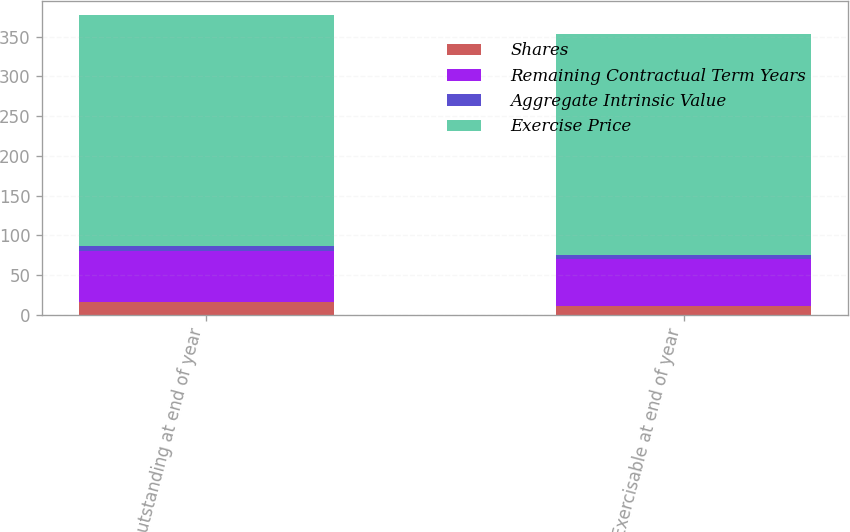<chart> <loc_0><loc_0><loc_500><loc_500><stacked_bar_chart><ecel><fcel>Outstanding at end of year<fcel>Exercisable at end of year<nl><fcel>Shares<fcel>15.7<fcel>11.3<nl><fcel>Remaining Contractual Term Years<fcel>64.82<fcel>58.26<nl><fcel>Aggregate Intrinsic Value<fcel>5.99<fcel>5.02<nl><fcel>Exercise Price<fcel>290.3<fcel>278.4<nl></chart> 